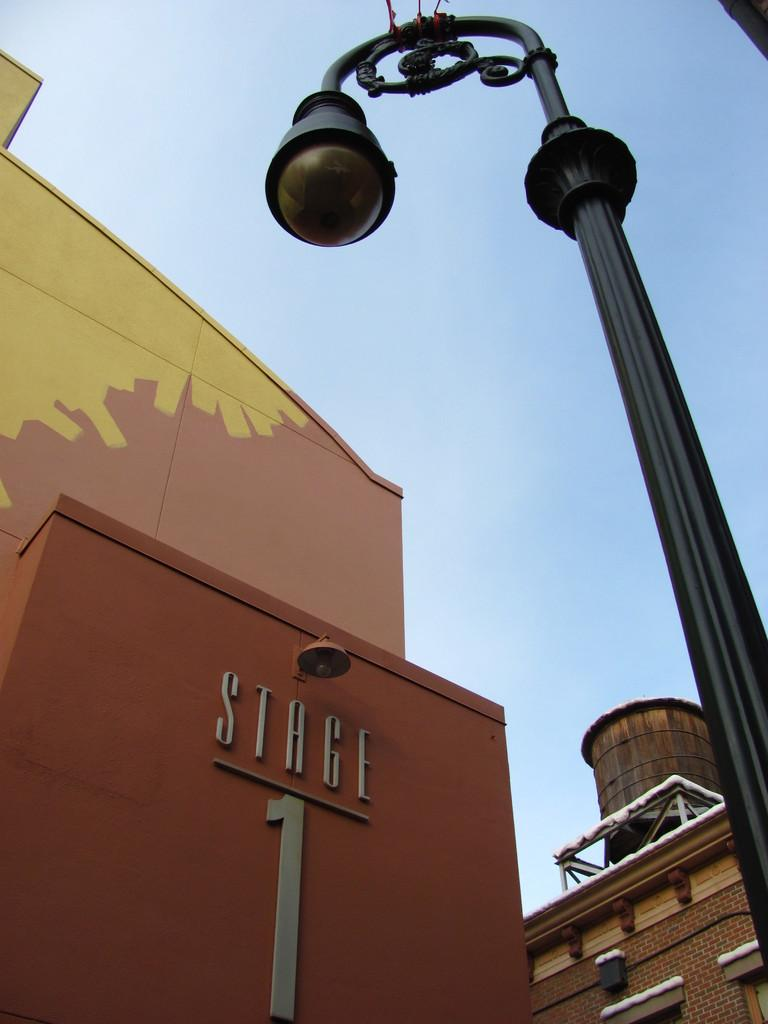What type of structures can be seen in the image? There are buildings in the image. What is the tall, vertical object in the image? There is a light pole in the image. Can you describe any other objects in the image? Yes, there are some objects in the image. What can be seen in the background of the image? The sky is visible in the background of the image. What type of locket is hanging from the light pole in the image? There is no locket present in the image; it only features a light pole and buildings. What type of market can be seen in the image? There is no market present in the image; it only features buildings, a light pole, and other objects. 